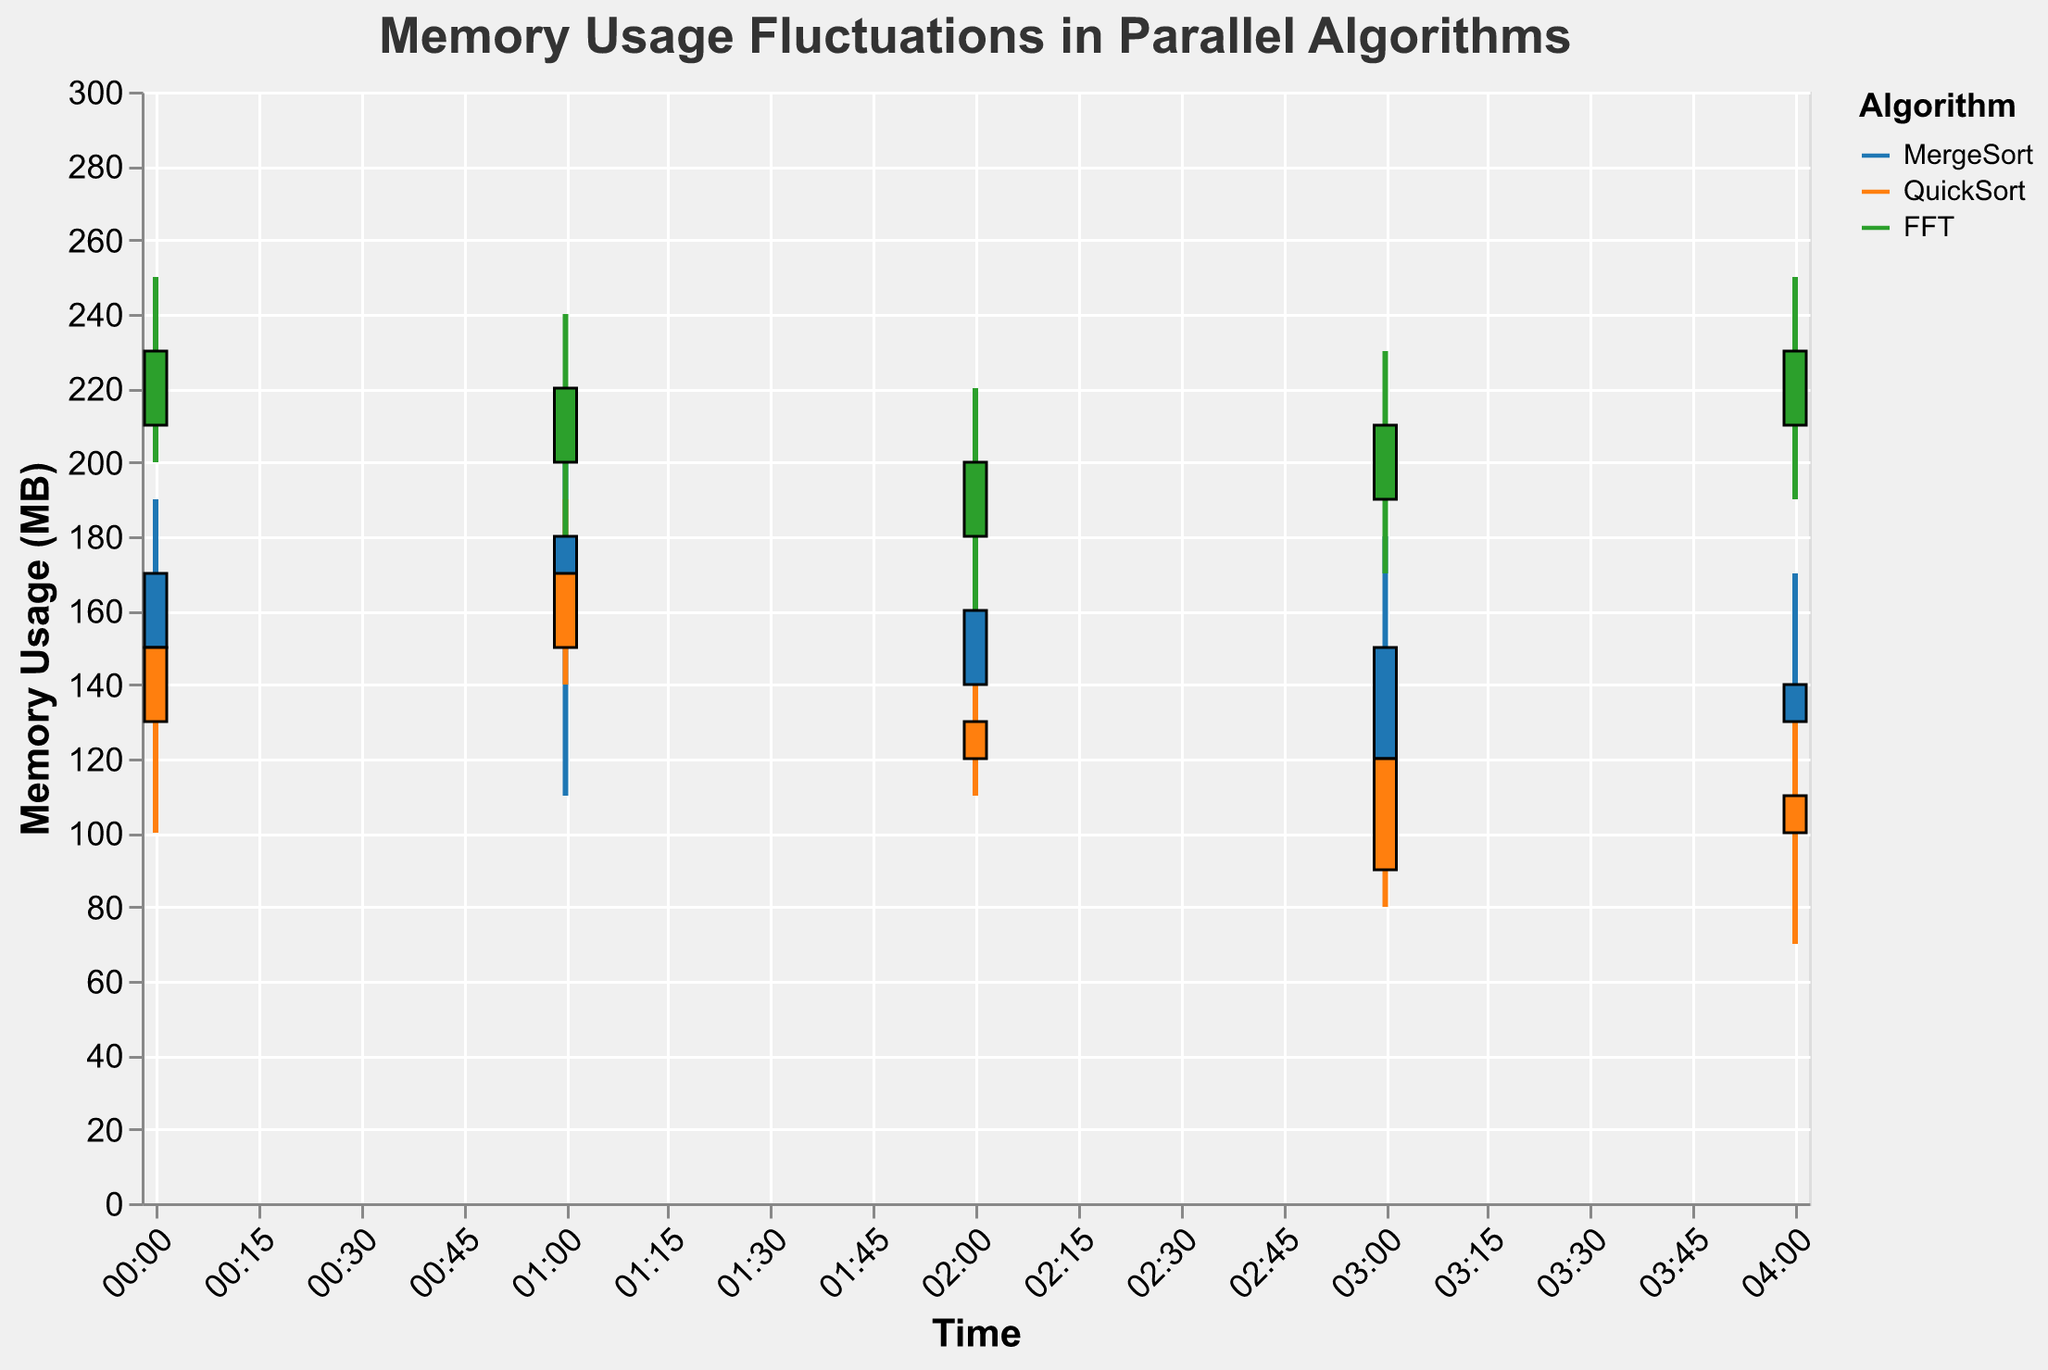What is the highest memory usage recorded for the MergeSort algorithm? To find the highest memory usage for MergeSort, observe the 'High' values on the y-axis and look for the maximum point for the MergeSort series. The highest value is 210 MB at 01:00.
Answer: 210 MB What is the average memory usage for the FFT algorithm across the given timestamps? To calculate the average memory usage for FFT, sum the 'High' values (250 + 240 + 220 + 230 + 250) and divide by the number of data points (5). Average = (250 + 240 + 220 + 230 + 250) / 5 = 238.
Answer: 238 MB Which algorithm shows the widest memory usage range at any timestamp? To determine the widest range, find the maximum difference between 'High' and 'Low' values for any algorithm. FFT at 2023-01-01 00:00:00 has the largest range (250 - 200 = 50 MB).
Answer: FFT For the QuickSort algorithm, at what time is the maximum memory usage higher than the maximum memory usage at 01:00? For QuickSort at 01:00, the 'High' value is 190. By comparing, only 00:00 has a higher 'High' value of 170 which is less than 190. Therefore, there is no time where QuickSort exceeds 190.
Answer: None During which timestamp does MergeSort experience the lowest memory usage? The lowest memory usage for MergeSort is found by identifying the 'Low' value over all timestamps, which is 90 at 2023-01-01 04:00:00.
Answer: 04:00 How much has the memory usage fluctuated (difference between 'High' and 'Low') for the QuickSort algorithm at 02:00? To find the fluctuation, subtract the 'Low' value from the 'High' value for QuickSort at 02:00: (150 - 110 = 40 MB).
Answer: 40 MB Between 00:00 and 01:00, which algorithm showed the greatest percentage increase in maximum memory usage? Calculate the percentage increase for each algorithm. For MergeSort, increase = ((210-190)/190)*100 = 10.53%. For QuickSort, increase = ((190-170)/170)*100 = 11.76%. For FFT, increase = ((240-250)/250)*100 = -4%. QuickSort has the highest percentage increase.
Answer: QuickSort At which timestamp does MergeSort use more memory than QuickSort? Compare 'High' values of MergeSort and QuickSort for each timestamp. MergeSort uses more memory at 00:00 (190 vs 170), 01:00 (210 vs 190), and 03:00 (180 vs 140).
Answer: 00:00, 01:00, 03:00 